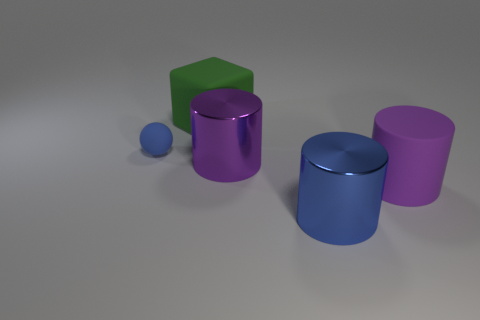Subtract all large blue cylinders. How many cylinders are left? 2 Add 4 green rubber blocks. How many objects exist? 9 Subtract all blue cylinders. How many cylinders are left? 2 Subtract all cubes. How many objects are left? 4 Subtract 1 cylinders. How many cylinders are left? 2 Subtract all red spheres. How many green cylinders are left? 0 Subtract all blue cylinders. Subtract all big purple metallic cylinders. How many objects are left? 3 Add 1 blue cylinders. How many blue cylinders are left? 2 Add 1 big yellow matte blocks. How many big yellow matte blocks exist? 1 Subtract 0 purple balls. How many objects are left? 5 